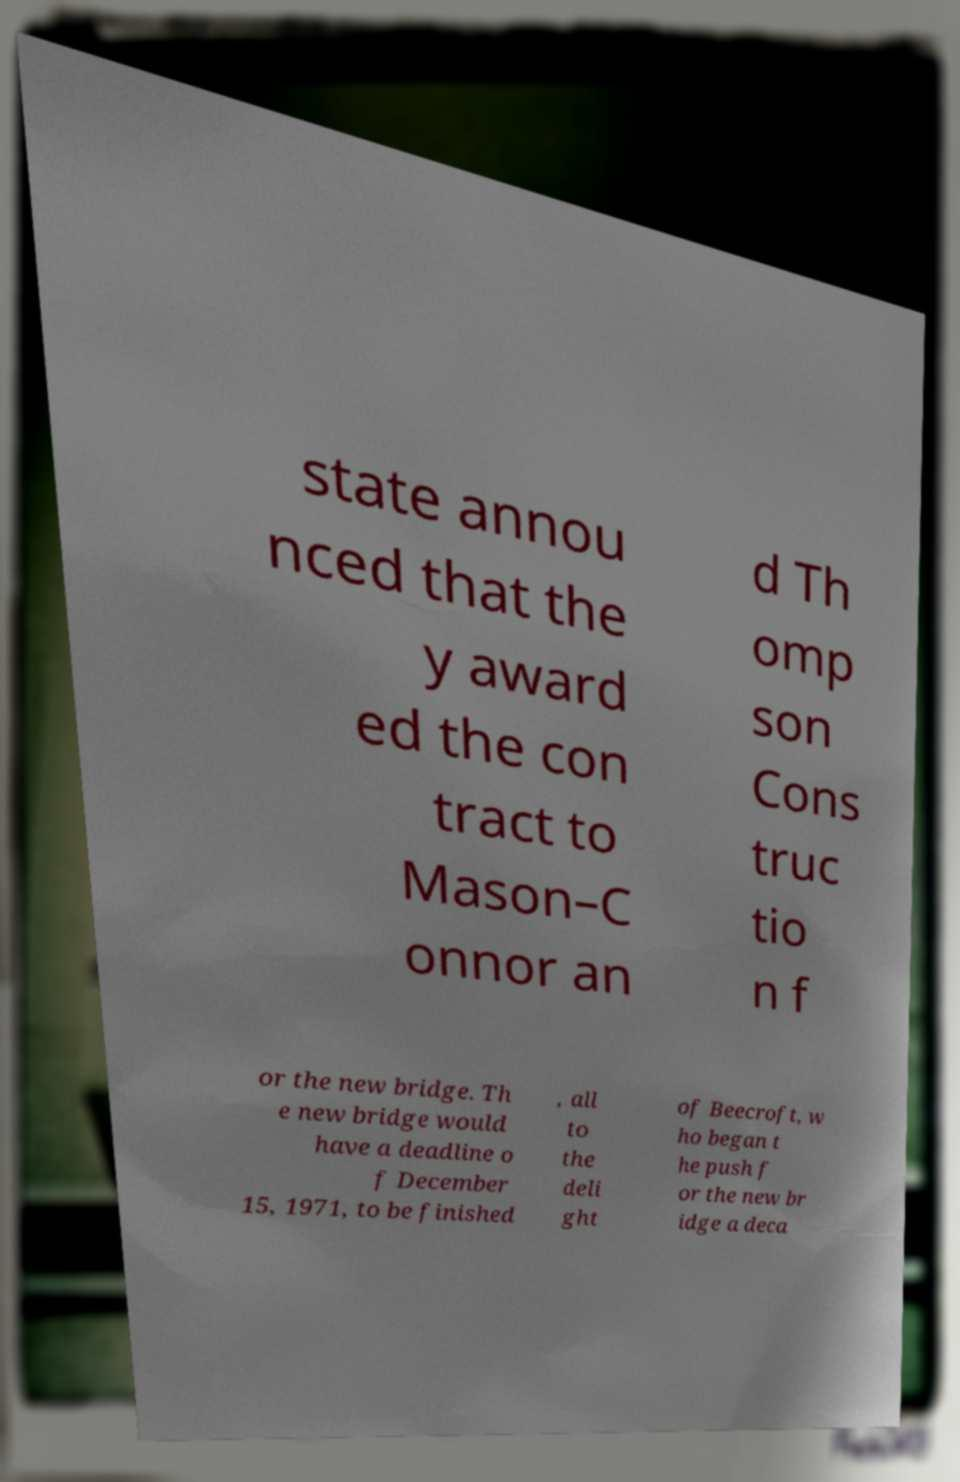Could you assist in decoding the text presented in this image and type it out clearly? state annou nced that the y award ed the con tract to Mason–C onnor an d Th omp son Cons truc tio n f or the new bridge. Th e new bridge would have a deadline o f December 15, 1971, to be finished , all to the deli ght of Beecroft, w ho began t he push f or the new br idge a deca 